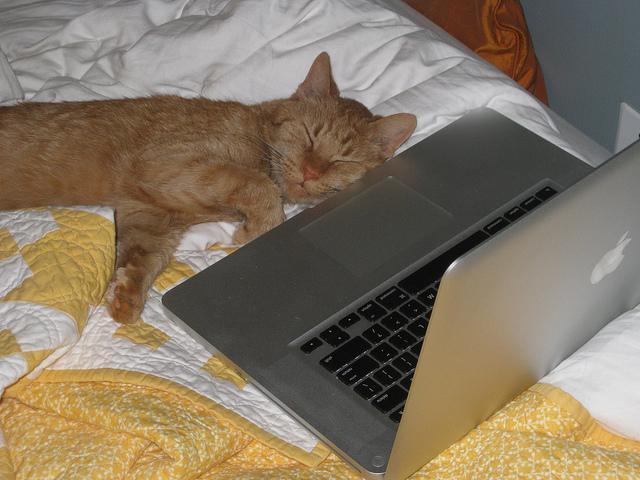How many paws do you see?
Give a very brief answer. 2. 